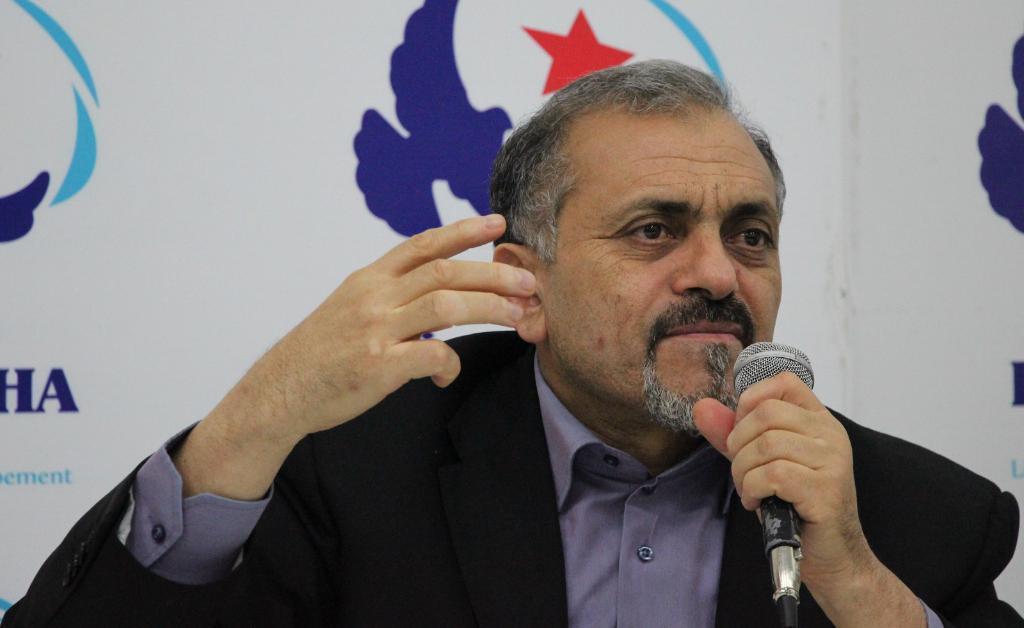Describe this image in one or two sentences. In this picture we can see man holding mic in his hand wore blazer and in background we can see banner. 